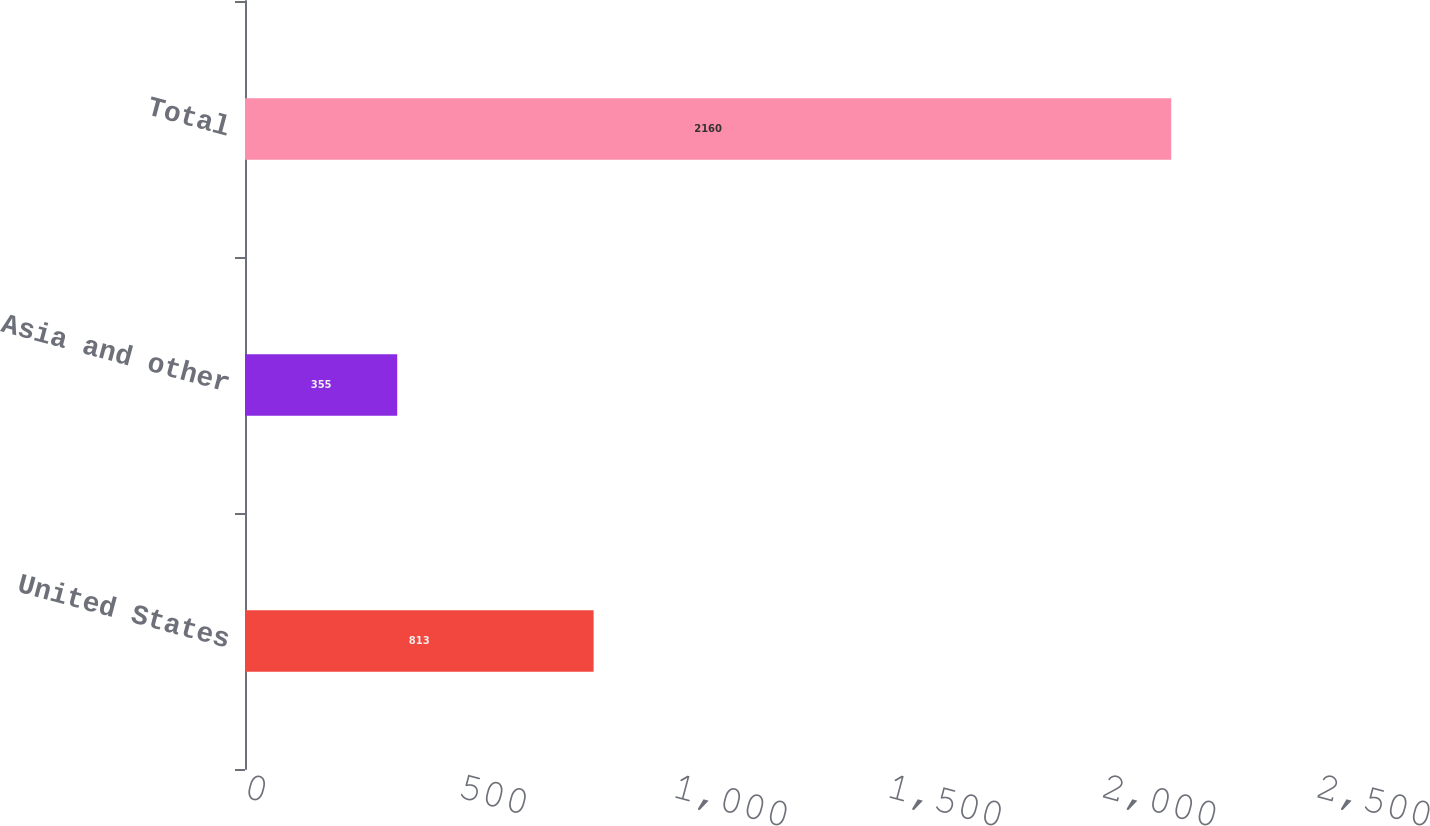Convert chart to OTSL. <chart><loc_0><loc_0><loc_500><loc_500><bar_chart><fcel>United States<fcel>Asia and other<fcel>Total<nl><fcel>813<fcel>355<fcel>2160<nl></chart> 